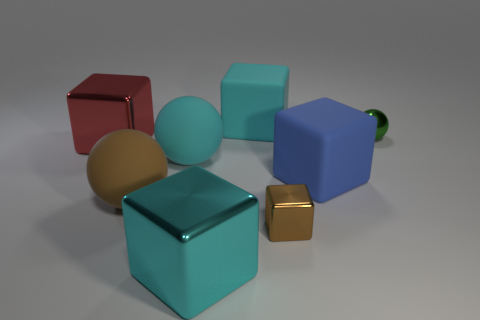Which objects in the image appear to have a reflective surface? The objects with a reflective surface in the image include the small gold cube and the beige sphere. You can tell by the way they reflect light and cast bright highlights. 